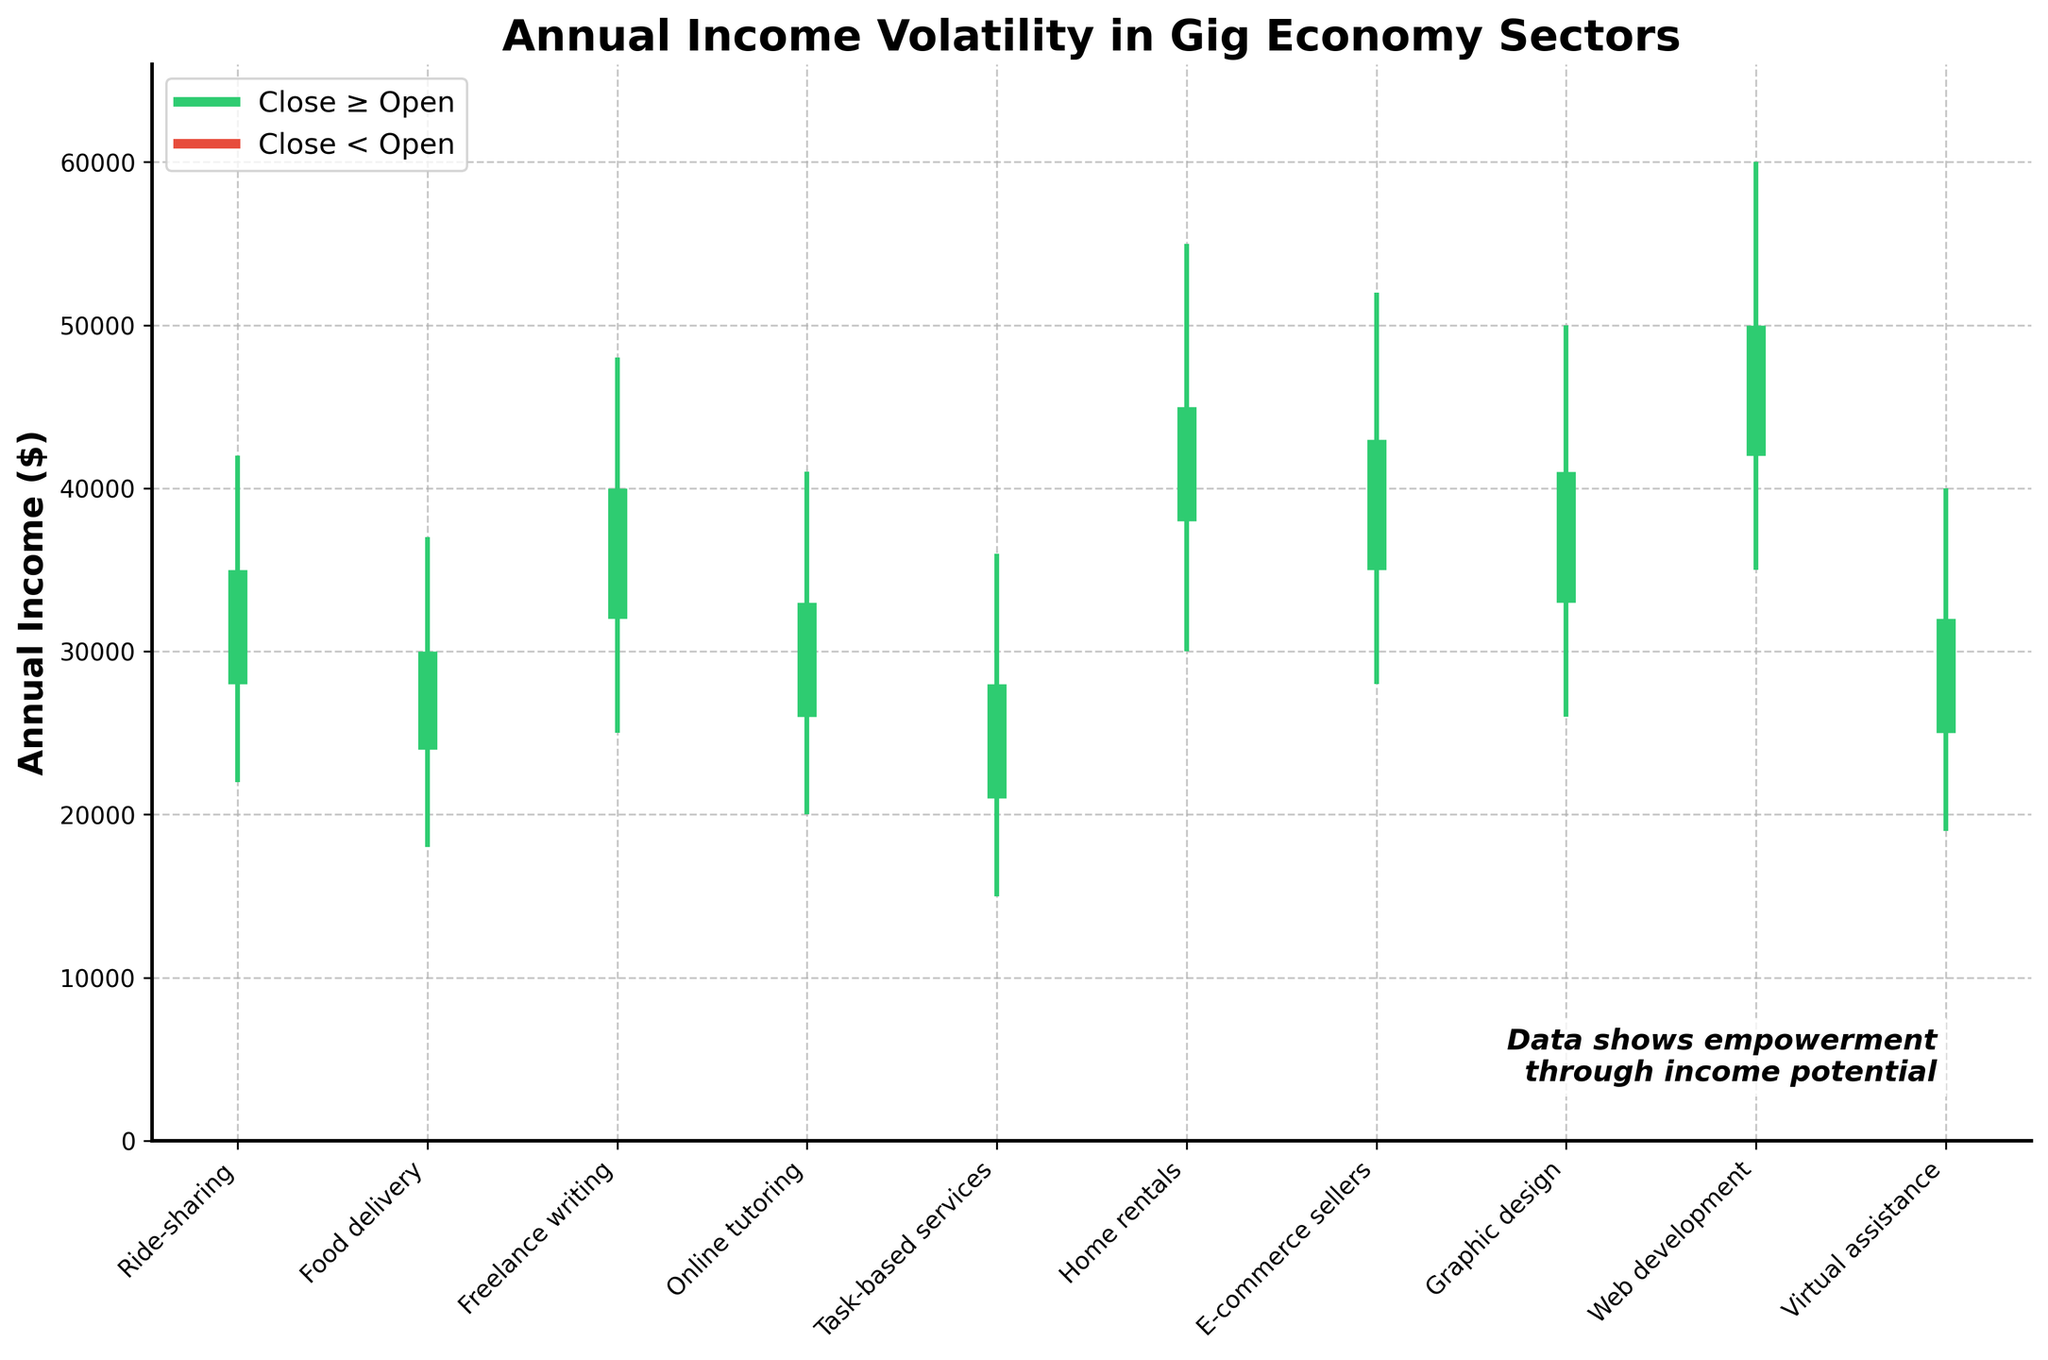What's the title of the chart? The title of the chart is prominently displayed at the top of the figure.
Answer: Annual Income Volatility in Gig Economy Sectors Which sector has the highest annual income range (difference between high and low)? To find the sector with the highest annual income range, subtract the lowest income from the highest income for each sector. The sector with the largest difference is the one with the highest range. Home rentals: 55000 - 30000 = 25000
Answer: Home rentals Which sector shows a decrease in annual income (where Close < Open)? The sectors where the closing income is less than the opening income are indicated by a specific color on the chart (down_color = red).
Answer: Food delivery, Task-based services, Virtual assistance What's the median closing income value for all sectors? First, list all closing incomes: 35000, 30000, 40000, 33000, 28000, 45000, 43000, 41000, 50000, 32000. Then, arrange them in ascending order: 28000, 30000, 32000, 33000, 35000, 40000, 41000, 43000, 45000, 50000. The median value (middle value in this sorted list) is the average of 5th and 6th values: (35000 + 40000) / 2 = 37500.
Answer: 37500 Which sector has the highest closing income? The highest closing income is determined by comparing the closing values of all sectors.
Answer: Web development What’s the average annual income (mean of High values) across all sectors? Sum all high values: 42000 + 37000 + 48000 + 41000 + 36000 + 55000 + 52000 + 50000 + 60000 + 40000 = 461000. Divide by the number of sectors (10). Average = 461000 / 10 = 46100.
Answer: 46100 What’s the difference in closing income between Web development and Graphic design? Find the closing incomes: Web development (50000), Graphic design (41000). Calculate the difference: 50000 - 41000 = 9000.
Answer: 9000 